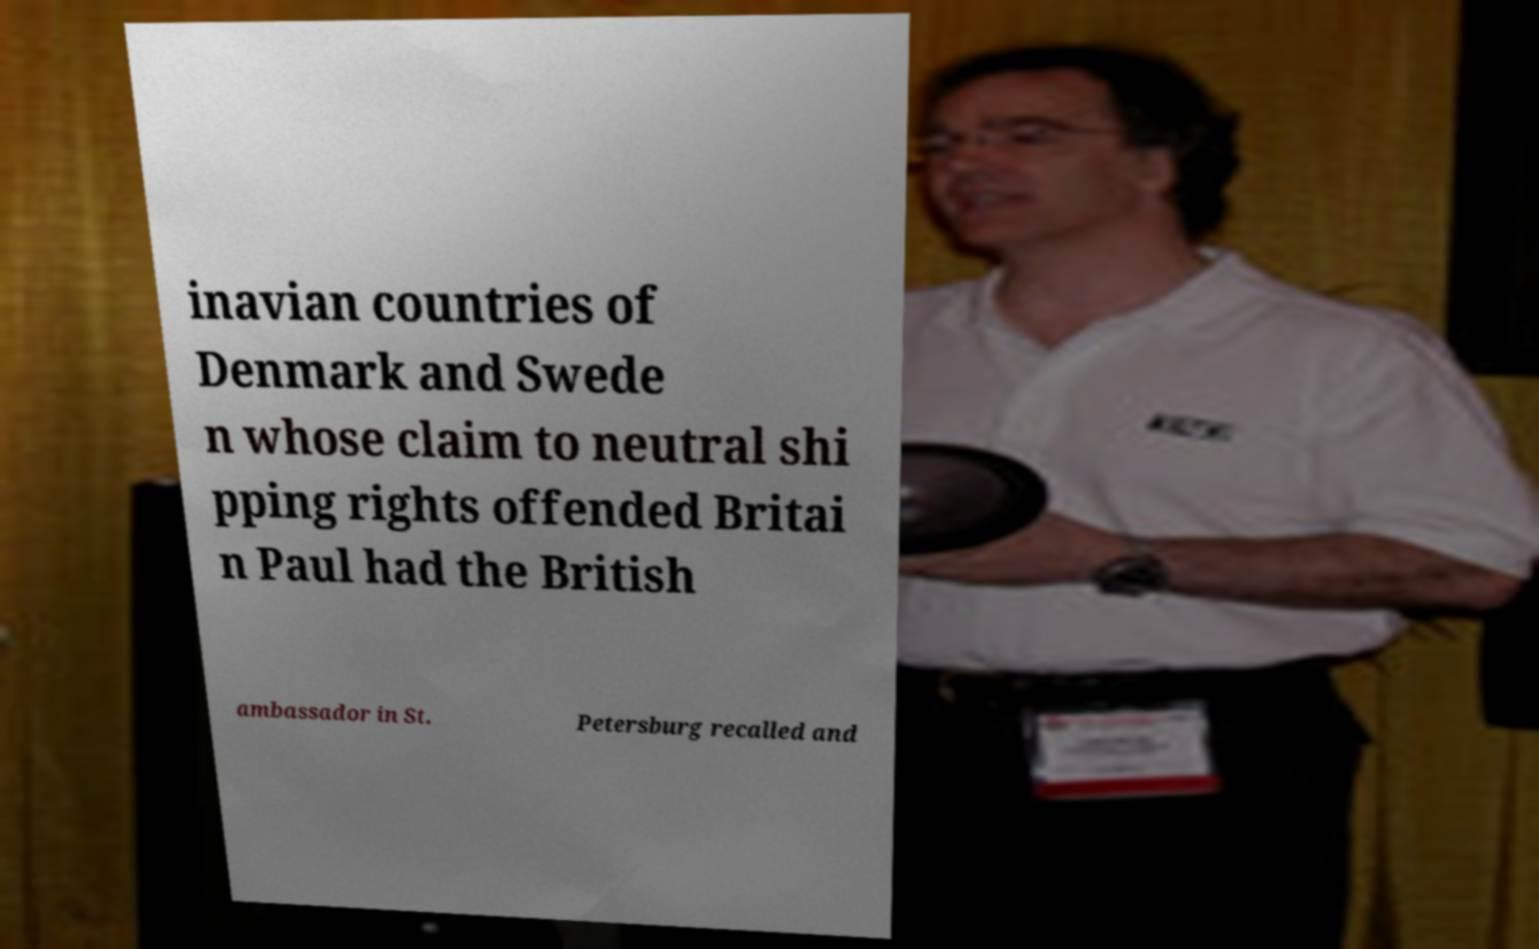Could you assist in decoding the text presented in this image and type it out clearly? inavian countries of Denmark and Swede n whose claim to neutral shi pping rights offended Britai n Paul had the British ambassador in St. Petersburg recalled and 